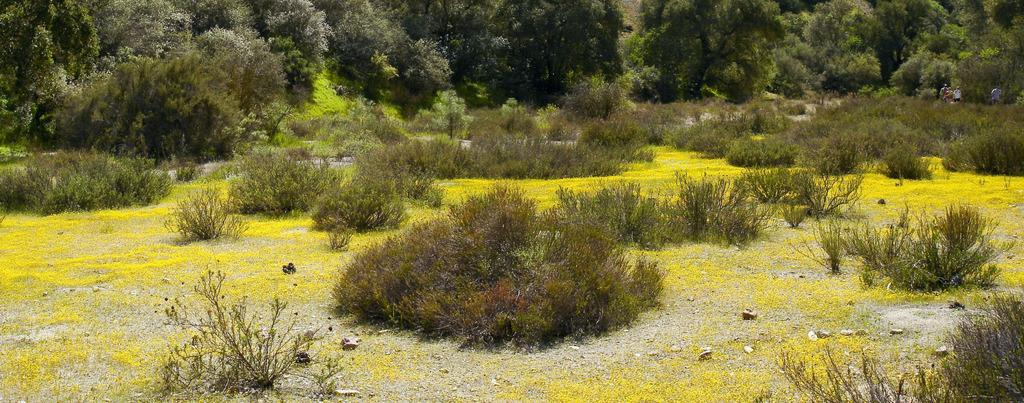What type of vegetation can be seen in the image? There is grass, plants, and trees visible in the image. Where are the plants located in the image? Plants are at the bottom of the image, and there are also plants and trees in the left and right corners of the image. Can you describe the people in the image? The image contains people, but their specific actions or characteristics are not mentioned in the provided facts. What is visible in the background of the image? There are plants and trees in the background of the image. What type of yam is being harvested by the people in the image? There is no mention of yams or any harvesting activity in the image. What season is depicted in the image, based on the presence of summer clothing? The provided facts do not mention any clothing or seasons, so it is impossible to determine the season depicted in the image. 